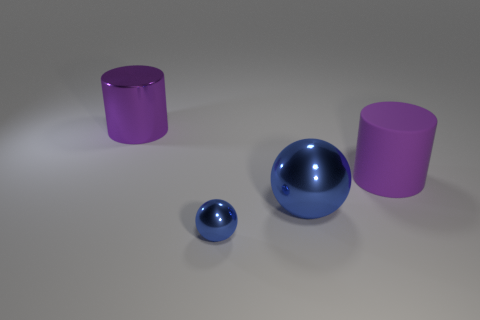Is there anything else that has the same material as the big blue sphere?
Provide a succinct answer. Yes. How many brown things are either large matte cylinders or small matte blocks?
Your answer should be compact. 0. Are there more big metallic cylinders behind the tiny sphere than tiny cyan objects?
Your answer should be compact. Yes. Does the rubber cylinder have the same size as the metal cylinder?
Your response must be concise. Yes. What is the color of the cylinder that is the same material as the large ball?
Offer a very short reply. Purple. What shape is the metal thing that is the same color as the large matte object?
Make the answer very short. Cylinder. Is the number of tiny metal spheres on the left side of the small blue metal ball the same as the number of cylinders that are behind the large blue sphere?
Give a very brief answer. No. There is a small blue shiny thing that is in front of the large purple shiny cylinder behind the matte thing; what is its shape?
Your answer should be very brief. Sphere. What is the material of the other purple object that is the same shape as the purple shiny object?
Keep it short and to the point. Rubber. There is a metal cylinder that is the same size as the matte cylinder; what is its color?
Make the answer very short. Purple. 